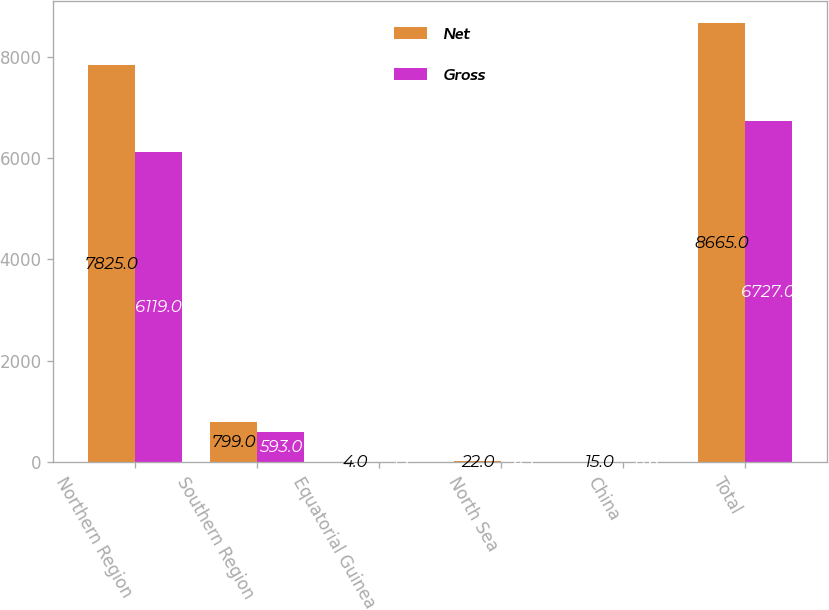Convert chart to OTSL. <chart><loc_0><loc_0><loc_500><loc_500><stacked_bar_chart><ecel><fcel>Northern Region<fcel>Southern Region<fcel>Equatorial Guinea<fcel>North Sea<fcel>China<fcel>Total<nl><fcel>Net<fcel>7825<fcel>799<fcel>4<fcel>22<fcel>15<fcel>8665<nl><fcel>Gross<fcel>6119<fcel>593<fcel>1.7<fcel>4.7<fcel>8.6<fcel>6727<nl></chart> 